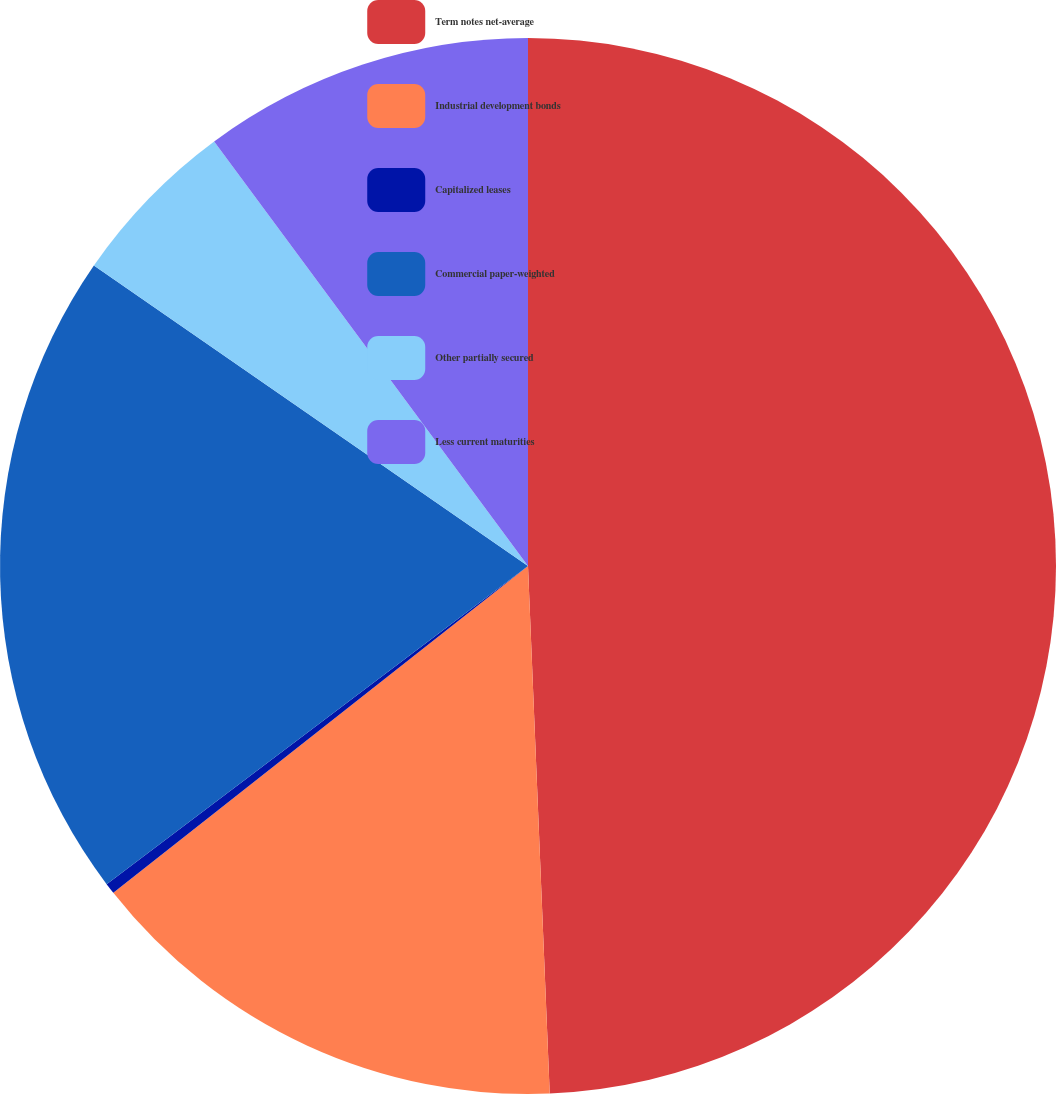Convert chart to OTSL. <chart><loc_0><loc_0><loc_500><loc_500><pie_chart><fcel>Term notes net-average<fcel>Industrial development bonds<fcel>Capitalized leases<fcel>Commercial paper-weighted<fcel>Other partially secured<fcel>Less current maturities<nl><fcel>49.34%<fcel>15.03%<fcel>0.33%<fcel>19.93%<fcel>5.23%<fcel>10.13%<nl></chart> 